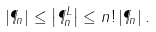Convert formula to latex. <formula><loc_0><loc_0><loc_500><loc_500>\left | \P _ { n } \right | \leq \left | \P ^ { L } _ { n } \right | \leq n ! \left | \P _ { n } \right | .</formula> 